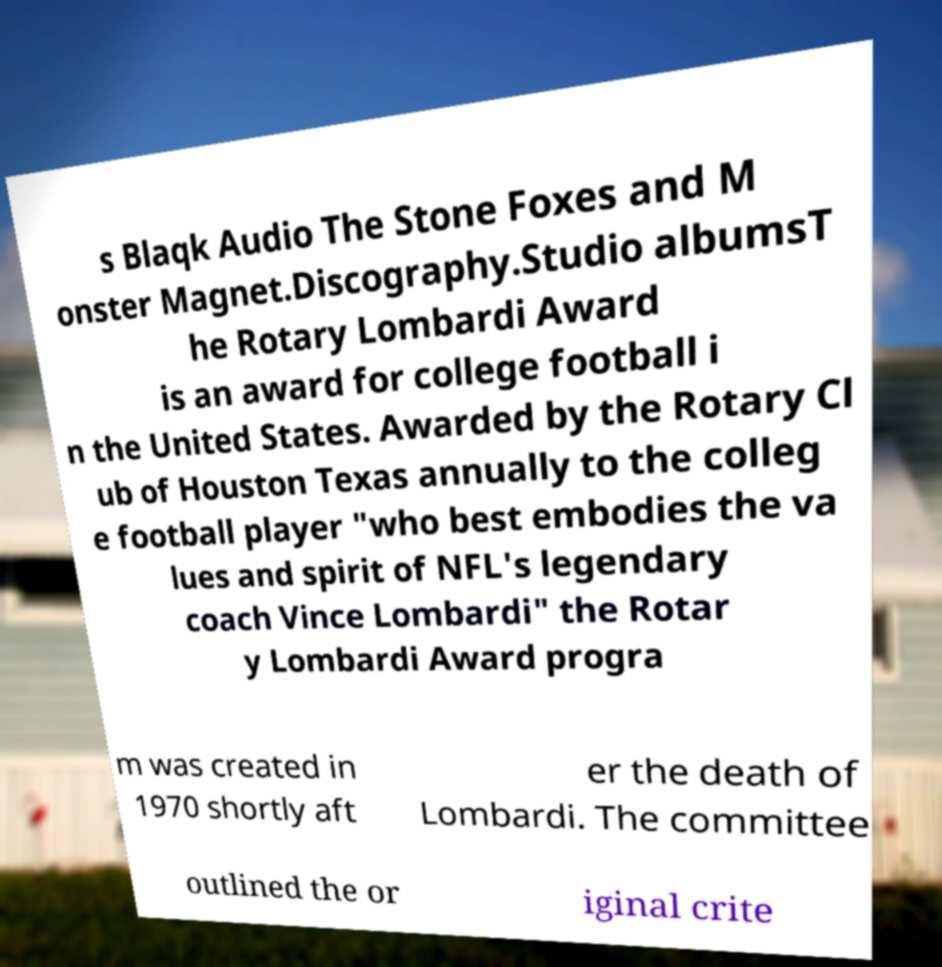Please identify and transcribe the text found in this image. s Blaqk Audio The Stone Foxes and M onster Magnet.Discography.Studio albumsT he Rotary Lombardi Award is an award for college football i n the United States. Awarded by the Rotary Cl ub of Houston Texas annually to the colleg e football player "who best embodies the va lues and spirit of NFL's legendary coach Vince Lombardi" the Rotar y Lombardi Award progra m was created in 1970 shortly aft er the death of Lombardi. The committee outlined the or iginal crite 